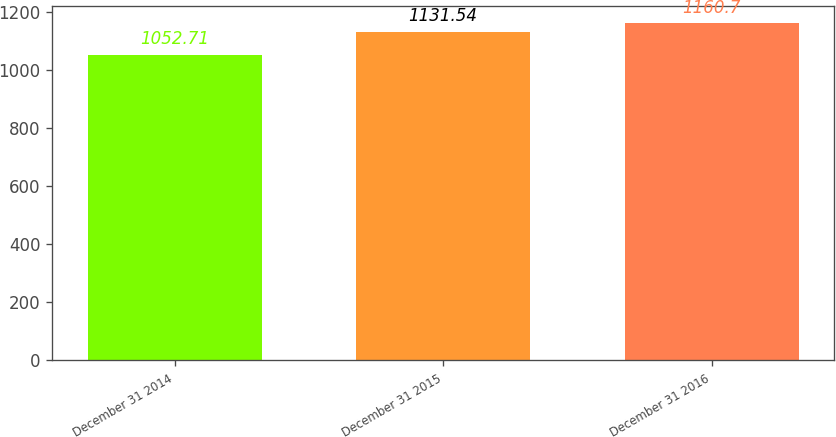Convert chart. <chart><loc_0><loc_0><loc_500><loc_500><bar_chart><fcel>December 31 2014<fcel>December 31 2015<fcel>December 31 2016<nl><fcel>1052.71<fcel>1131.54<fcel>1160.7<nl></chart> 